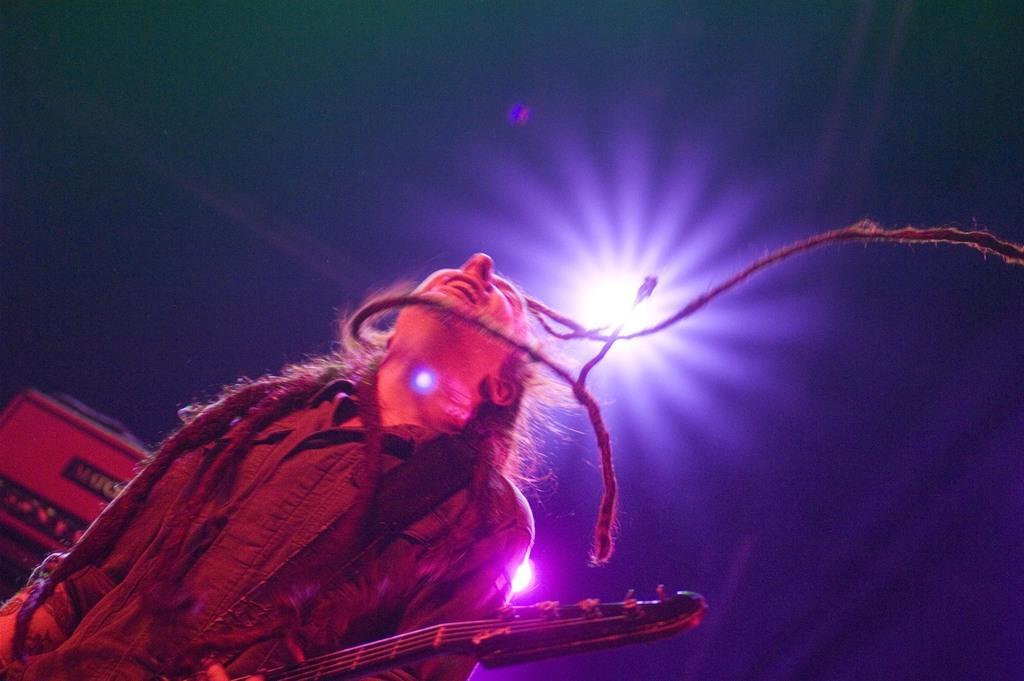Could you give a brief overview of what you see in this image? This picture is clicked in a musical concert. The man at the bottom of the picture wearing black shirt is holding a guitar in his hand and he is playing it and I think he is singing the song. Behind him, we see a musical instrument and it is dark in the background. 